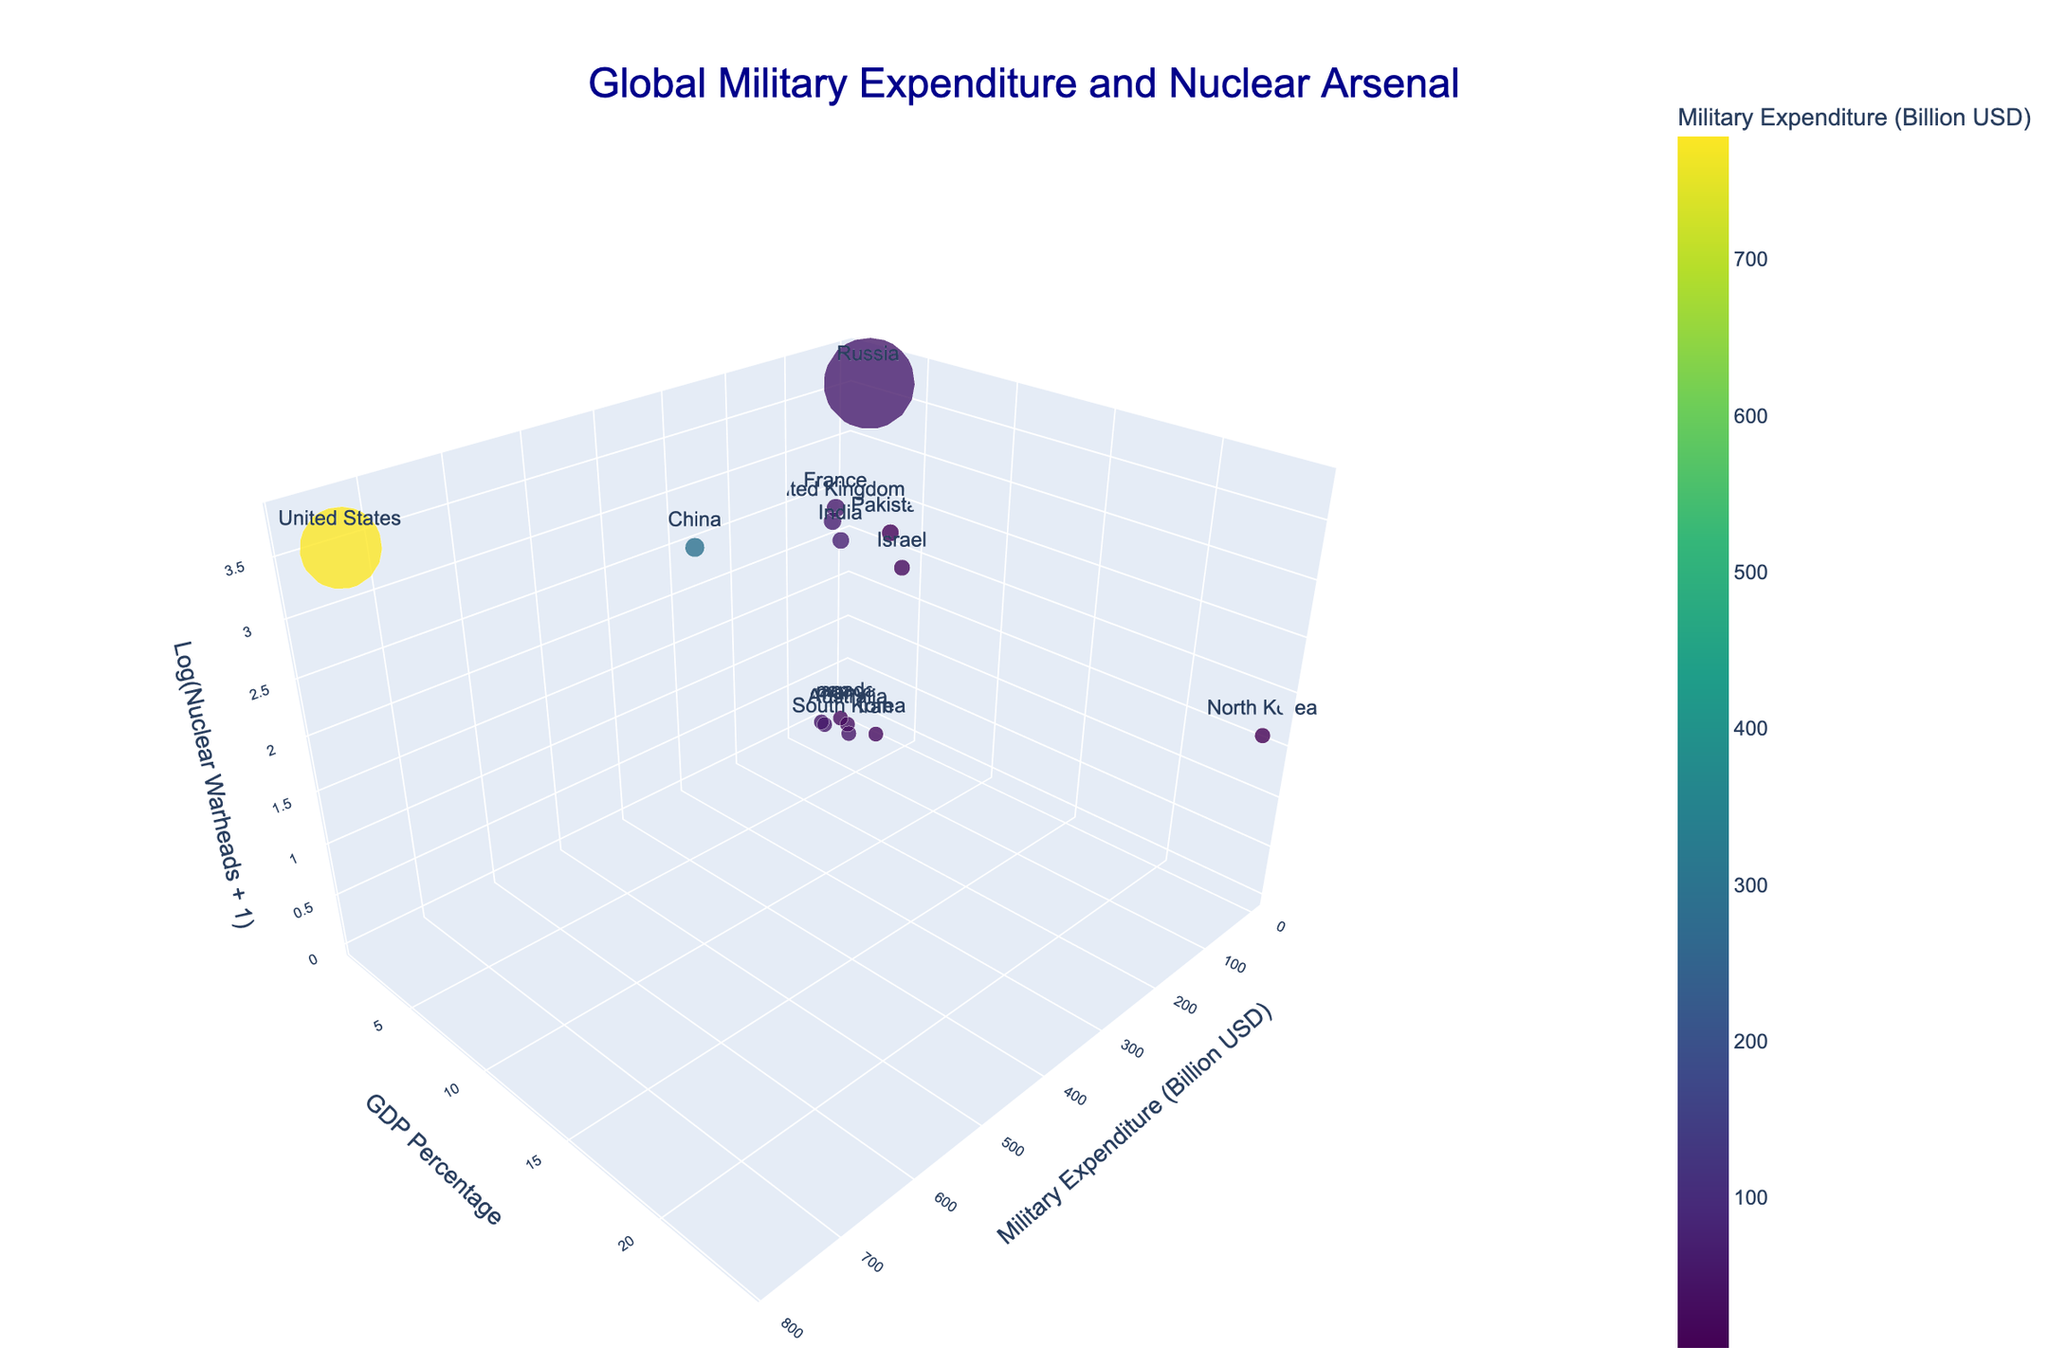What does the title of the chart indicate? The title "Global Military Expenditure and Nuclear Arsenal" indicates that the chart showcases countries' military spending in billion USD and their nuclear arsenal sizes. This suggests the chart provides a comparative analysis of military budgets and nuclear capabilities.
Answer: Global Military Expenditure and Nuclear Arsenal How is the size of the bubbles determined? The size of the bubbles represents the nuclear arsenals of the countries. Larger bubbles indicate a larger number of nuclear warheads.
Answer: Nuclear arsenals Which country has the highest military expenditure displayed in the chart? By examining the position of the bubbles along the x-axis (Military Expenditure in Billion USD), it is clear that the United States has the highest military expenditure, as it is positioned the furthest along the x-axis.
Answer: United States What does the z-axis represent in the chart? The z-axis represents the logarithm of the nuclear warheads plus one, indicating the relative size of nuclear arsenals in a normalized scale. This allows a wide range of values to be compared more effectively.
Answer: Logarithm of Nuclear Warheads + 1 Which country has the lowest GDP percentage among the ones displayed in the chart? By observing the positions along the y-axis (GDP Percentage), Japan has the lowest GDP percentage dedicated to military expenditure, at 1.0%.
Answer: Japan Compare the military expenditure of the top two spenders. The United States spends 778 billion USD, while China spends 293 billion USD. Comparing these values shows that the U.S. spends significantly more than China on military expenditures.
Answer: The U.S. spends 778 billion USD, China spends 293 billion USD How do North Korea's military expenditure and nuclear arsenal compare to other countries? North Korea has a military expenditure of 4.0 billion USD and a nuclear arsenal of 40 warheads. Despite a relatively low military budget, North Korea's nuclear arsenal is notable but still small compared to nuclear superpowers like the U.S. or Russia.
Answer: Low expenditure, small arsenal Identify a country with high military expenditure but no nuclear warheads. Germany stands out as it has a military expenditure of 56.0 billion USD but no nuclear warheads, as represented by its position with a z-value close to zero.
Answer: Germany Which countries allocate more than 4% of their GDP to military expenditure? By examining bubbles with a y-axis value greater than 4%, Russia (4.1%), Pakistan (4.0%), and Israel (5.2%) meet this criterion.
Answer: Russia, Pakistan, Israel How does the nuclear arsenal affect the positioning of bubbles on the z-axis? The z-axis uses the logarithm of the number of nuclear warheads plus one. Thus, higher nuclear arsenals translate to higher z-axis positions. For example, Russia and the United States are high on the z-axis due to their large nuclear arsenals, while countries with no nuclear warheads have z-values close to zero.
Answer: Larger arsenals have higher z-values 